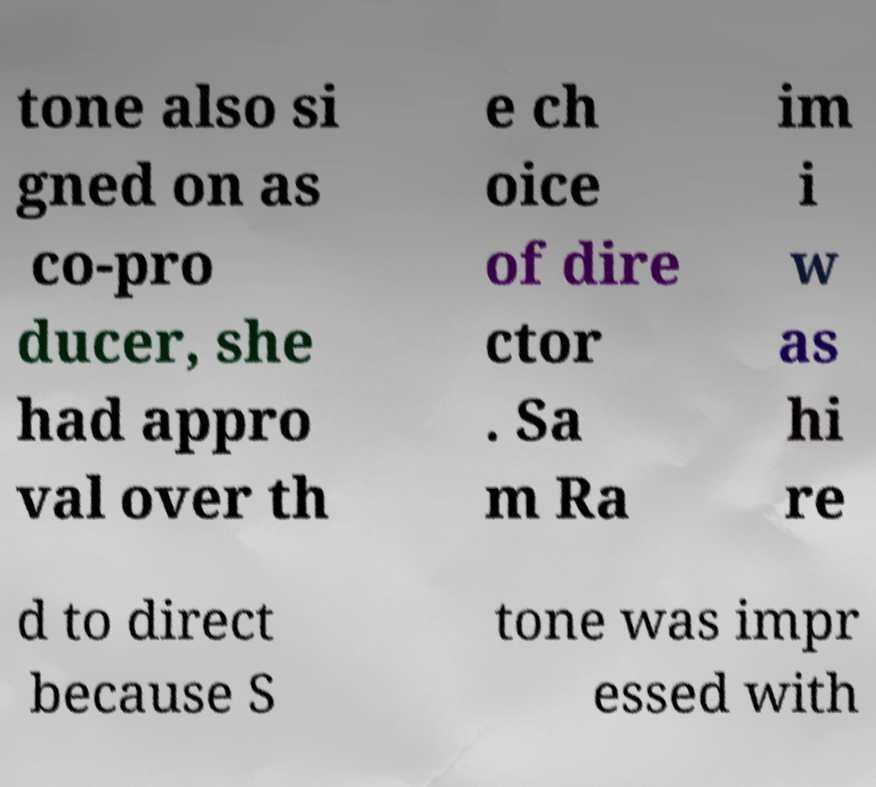What messages or text are displayed in this image? I need them in a readable, typed format. tone also si gned on as co-pro ducer, she had appro val over th e ch oice of dire ctor . Sa m Ra im i w as hi re d to direct because S tone was impr essed with 